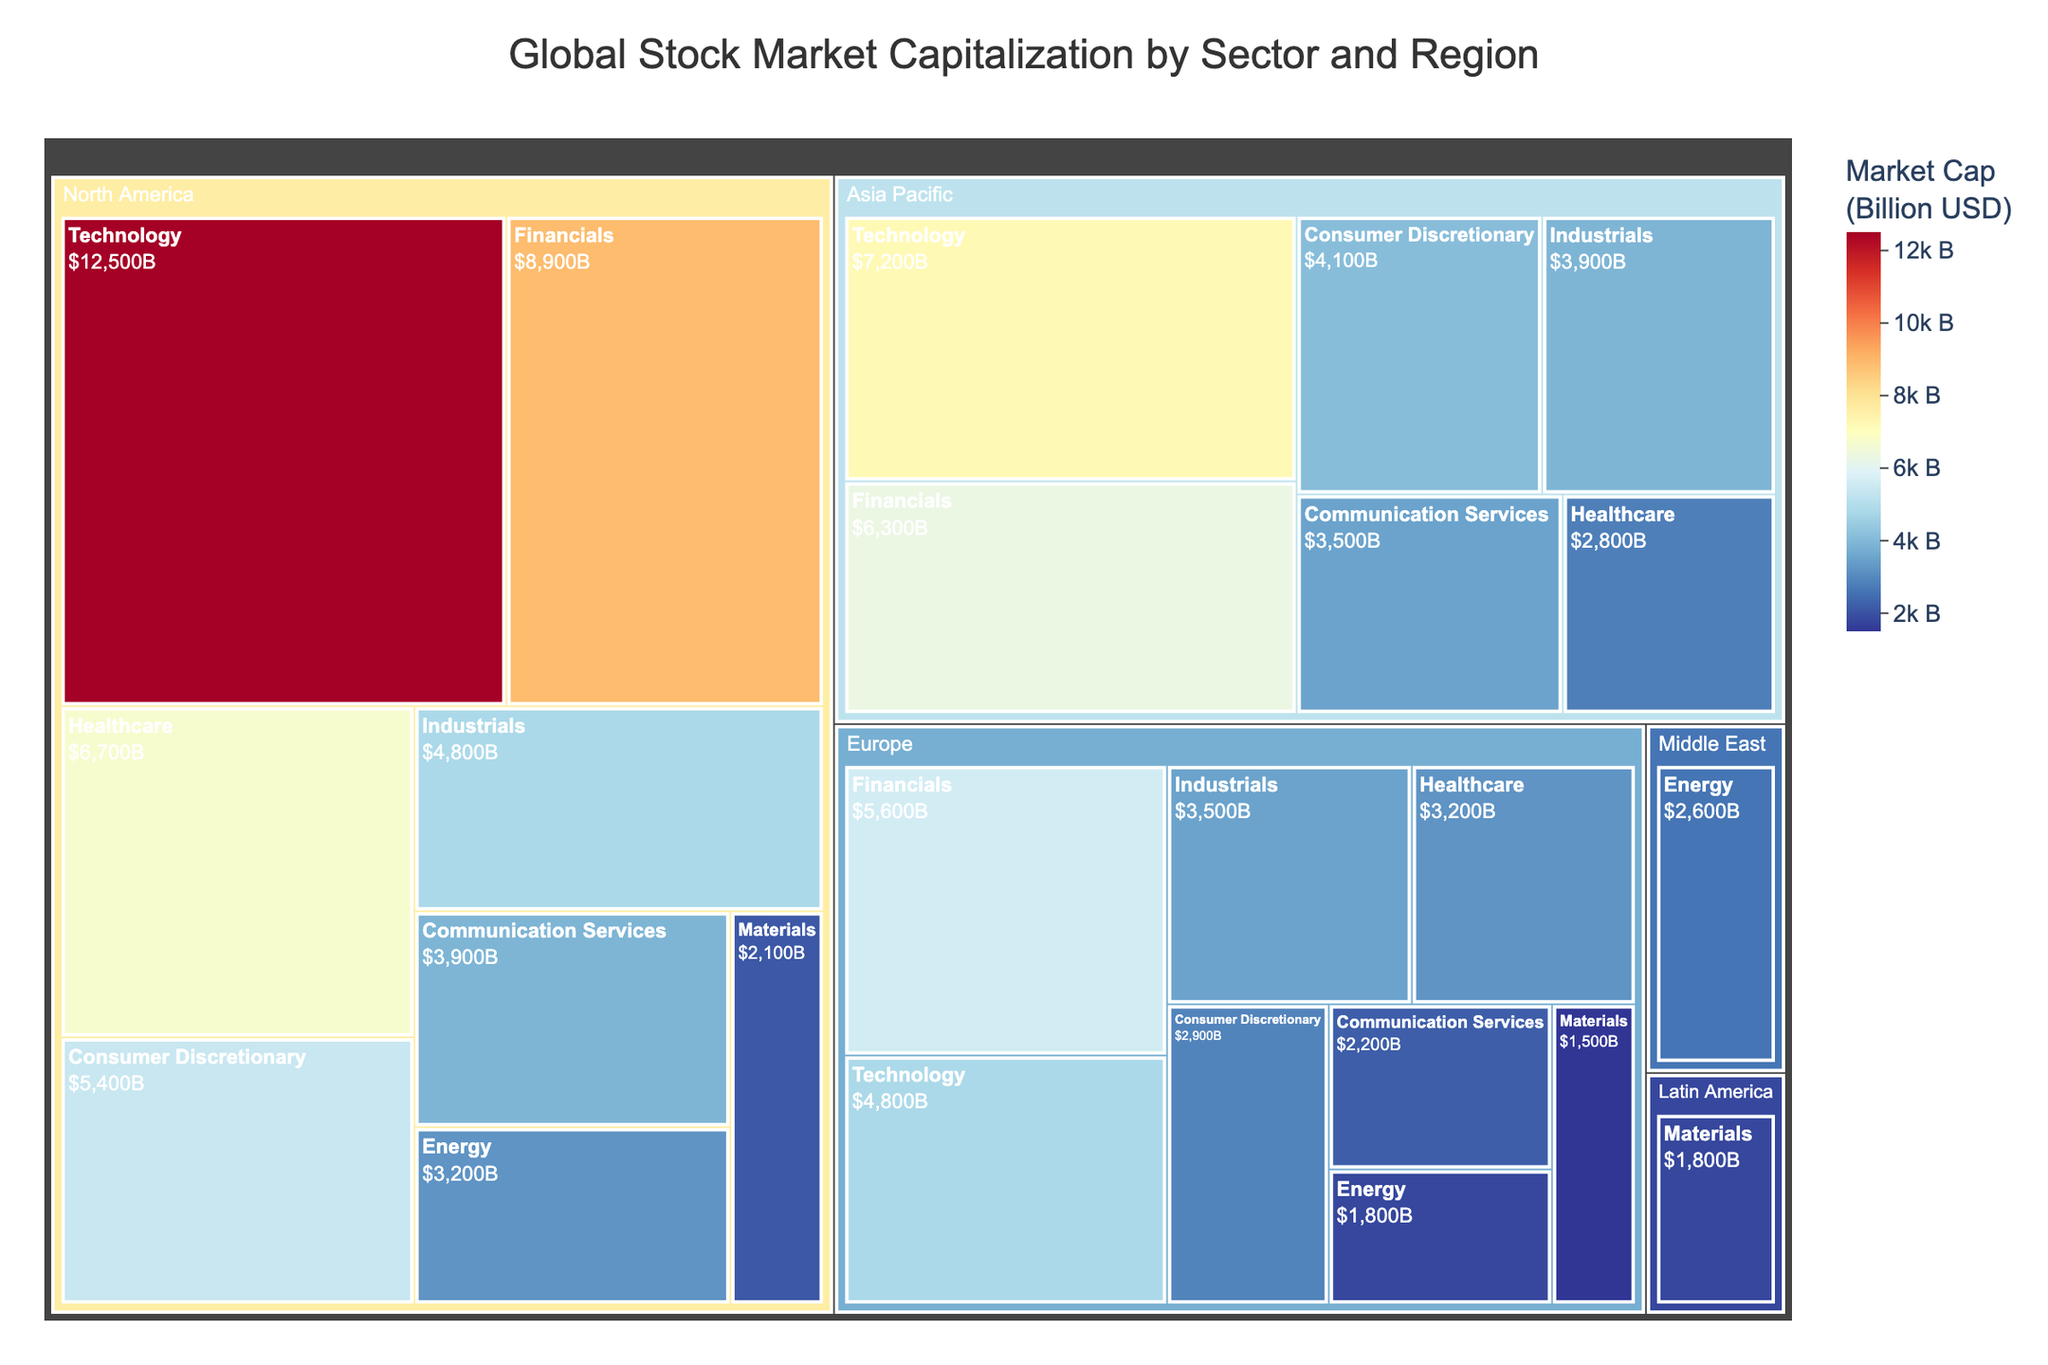What is the title of the treemap? Look at the top of the figure where the title is displayed.
Answer: Global Stock Market Capitalization by Sector and Region Which sector has the highest market capitalization in North America? Locate the North America region on the treemap and identify which sector occupies the largest area.
Answer: Technology How much larger is the market capitalization of Healthcare in North America compared to Asia Pacific? Identify the market capitalization values of Healthcare in North America and Asia Pacific and calculate the difference.
Answer: 3,900 Which region has the smallest market capitalization for the Materials sector? Locate the sector "Materials" in the treemap and compare the areas occupied by each region.
Answer: Europe What is the total market capitalization for the Financials sector globally? Sum the market capitalization of Financials across all regions.
Answer: 20,800 Which sector has a blue color in the treemap? Blue shades typically represent higher values; find the sector with the blue shade to determine.
Answer: Technology Compare the market capitalization of Energy in North America to that in Europe. Which one is higher? Find the market capitalization values for Energy in North America and Europe and compare them.
Answer: North America What is the average market capitalization of the Consumer Discretionary sector across all regions? Sum the market capitalization values for Consumer Discretionary in all regions and divide by the number of regions.
Answer: 4,133.33 Which sector in Asia Pacific has the smallest market capitalization? Within the Asia Pacific region on the treemap, identify the smallest area corresponding to a sector.
Answer: Healthcare Which region contributes the most to the global Technology sector market capitalization? Identify the region contributing the largest market capitalization to the Technology sector in the treemap.
Answer: North America 